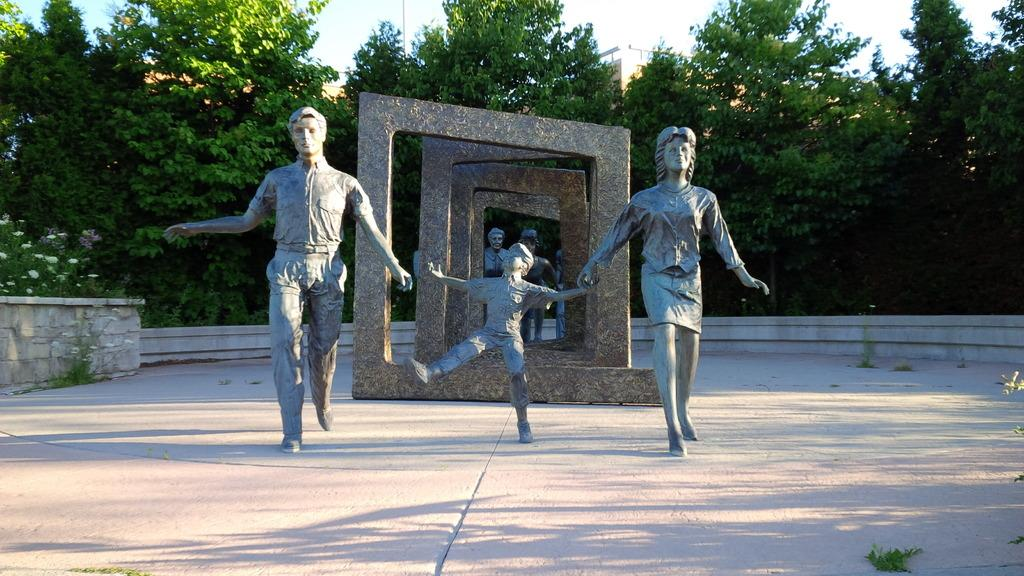What type of objects can be seen in the image? There are statues in the image. What architectural features are present in the image? There are arch structures in the image. What can be seen in the background of the image? There are trees and buildings in the background of the image. What type of iron is being used by the crook in the image? There is no crook or iron present in the image; it features statues and arch structures. 